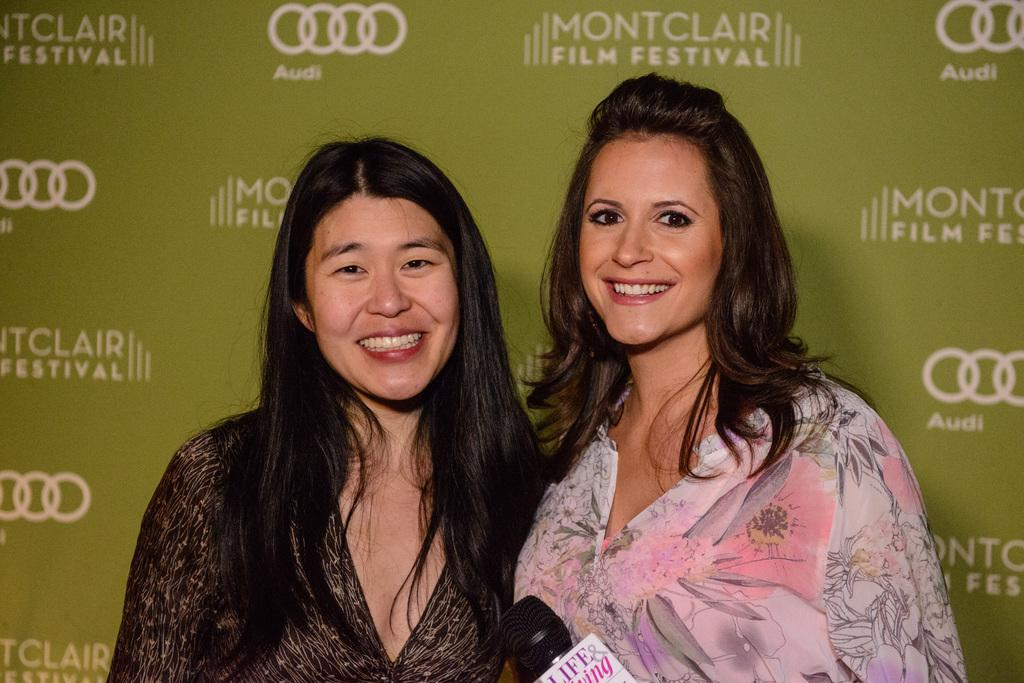How many people are in the image? There are two women standing in the image. What is located at the bottom of the image? There is a mic at the bottom of the image. Is there any text visible in the image? Yes, there is text visible on the backside of the image. Are there any chains visible in the image? No, there are no chains present in the image. Who is the writer of the text on the backside of the image? The image does not show a writer or any indication of who wrote the text. 